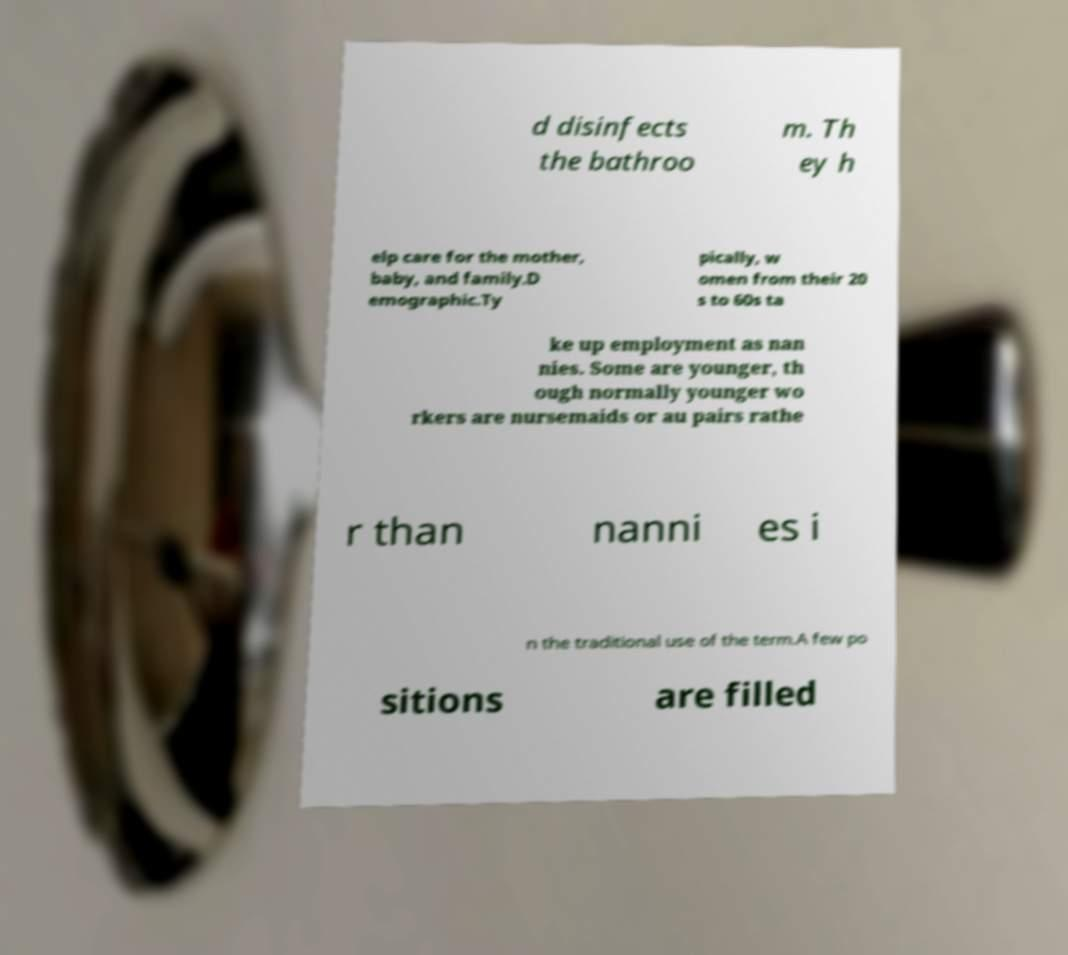Can you read and provide the text displayed in the image?This photo seems to have some interesting text. Can you extract and type it out for me? d disinfects the bathroo m. Th ey h elp care for the mother, baby, and family.D emographic.Ty pically, w omen from their 20 s to 60s ta ke up employment as nan nies. Some are younger, th ough normally younger wo rkers are nursemaids or au pairs rathe r than nanni es i n the traditional use of the term.A few po sitions are filled 